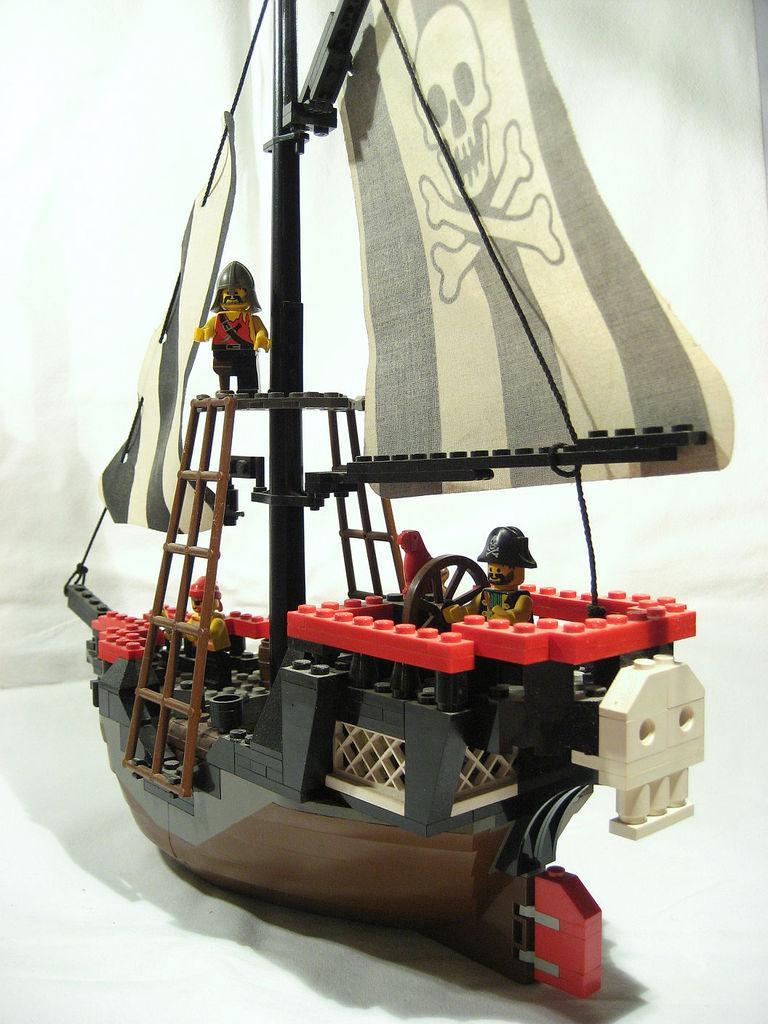In one or two sentences, can you explain what this image depicts? This looks like a LEGO puzzle of a ship. These are the ladders. I can see three men standing. This looks like a steering wheel. The background looks white in color. 